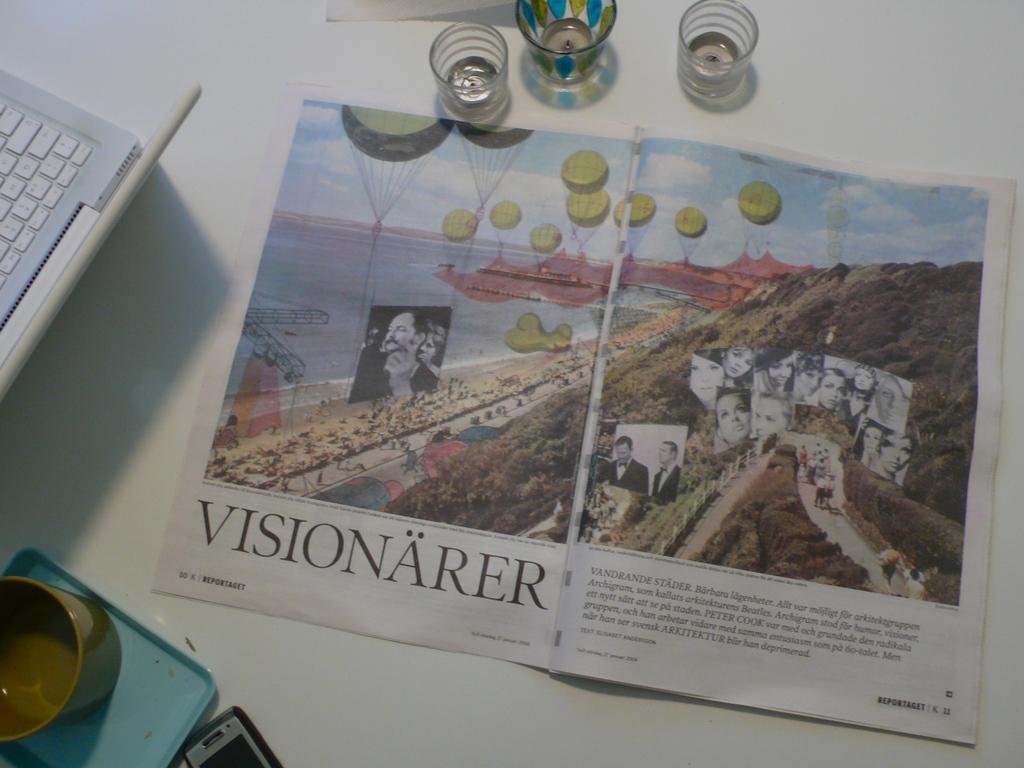What is the name of the newspaper article?
Offer a very short reply. Visionarer. Which letter has an accent over it in the biggest word?
Your answer should be compact. A. 